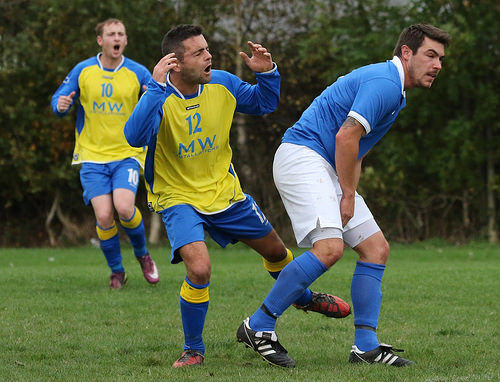<image>
Is the cleat in front of the sock? No. The cleat is not in front of the sock. The spatial positioning shows a different relationship between these objects. 